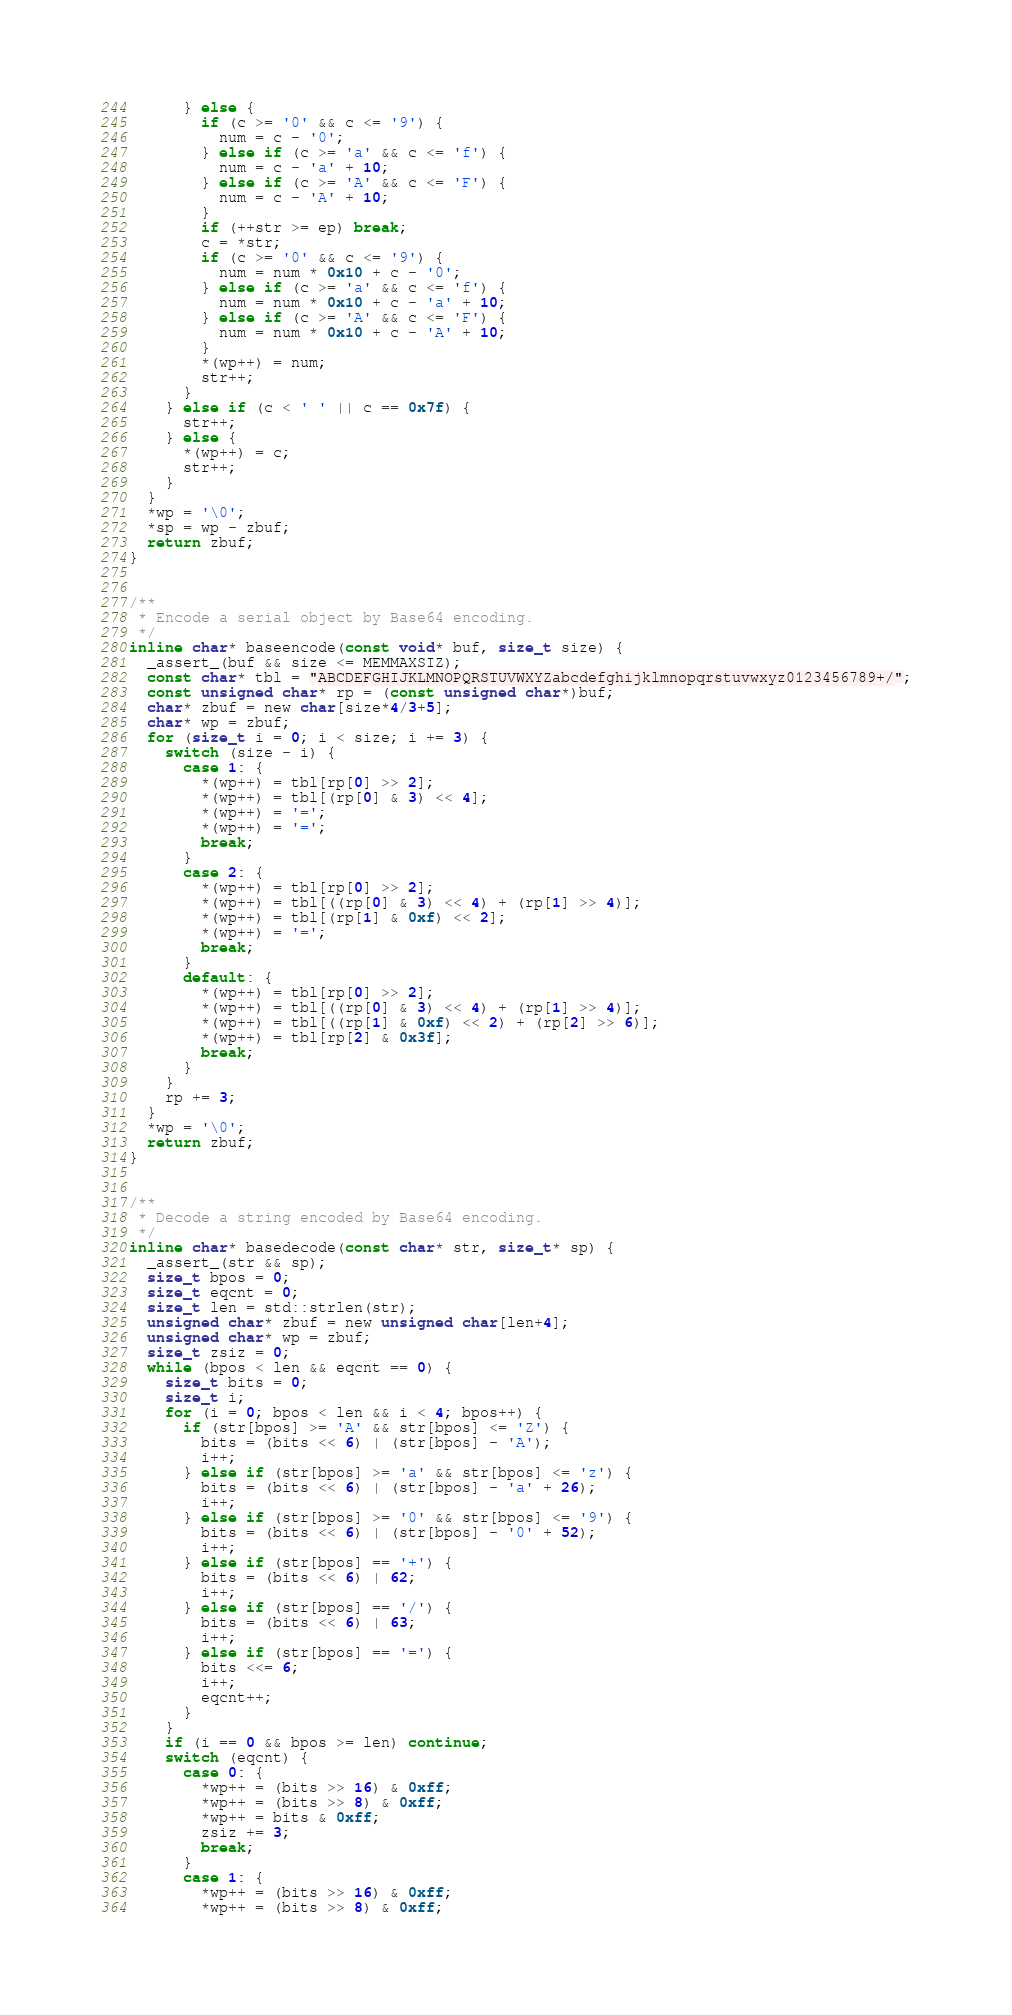<code> <loc_0><loc_0><loc_500><loc_500><_C_>      } else {
        if (c >= '0' && c <= '9') {
          num = c - '0';
        } else if (c >= 'a' && c <= 'f') {
          num = c - 'a' + 10;
        } else if (c >= 'A' && c <= 'F') {
          num = c - 'A' + 10;
        }
        if (++str >= ep) break;
        c = *str;
        if (c >= '0' && c <= '9') {
          num = num * 0x10 + c - '0';
        } else if (c >= 'a' && c <= 'f') {
          num = num * 0x10 + c - 'a' + 10;
        } else if (c >= 'A' && c <= 'F') {
          num = num * 0x10 + c - 'A' + 10;
        }
        *(wp++) = num;
        str++;
      }
    } else if (c < ' ' || c == 0x7f) {
      str++;
    } else {
      *(wp++) = c;
      str++;
    }
  }
  *wp = '\0';
  *sp = wp - zbuf;
  return zbuf;
}


/**
 * Encode a serial object by Base64 encoding.
 */
inline char* baseencode(const void* buf, size_t size) {
  _assert_(buf && size <= MEMMAXSIZ);
  const char* tbl = "ABCDEFGHIJKLMNOPQRSTUVWXYZabcdefghijklmnopqrstuvwxyz0123456789+/";
  const unsigned char* rp = (const unsigned char*)buf;
  char* zbuf = new char[size*4/3+5];
  char* wp = zbuf;
  for (size_t i = 0; i < size; i += 3) {
    switch (size - i) {
      case 1: {
        *(wp++) = tbl[rp[0] >> 2];
        *(wp++) = tbl[(rp[0] & 3) << 4];
        *(wp++) = '=';
        *(wp++) = '=';
        break;
      }
      case 2: {
        *(wp++) = tbl[rp[0] >> 2];
        *(wp++) = tbl[((rp[0] & 3) << 4) + (rp[1] >> 4)];
        *(wp++) = tbl[(rp[1] & 0xf) << 2];
        *(wp++) = '=';
        break;
      }
      default: {
        *(wp++) = tbl[rp[0] >> 2];
        *(wp++) = tbl[((rp[0] & 3) << 4) + (rp[1] >> 4)];
        *(wp++) = tbl[((rp[1] & 0xf) << 2) + (rp[2] >> 6)];
        *(wp++) = tbl[rp[2] & 0x3f];
        break;
      }
    }
    rp += 3;
  }
  *wp = '\0';
  return zbuf;
}


/**
 * Decode a string encoded by Base64 encoding.
 */
inline char* basedecode(const char* str, size_t* sp) {
  _assert_(str && sp);
  size_t bpos = 0;
  size_t eqcnt = 0;
  size_t len = std::strlen(str);
  unsigned char* zbuf = new unsigned char[len+4];
  unsigned char* wp = zbuf;
  size_t zsiz = 0;
  while (bpos < len && eqcnt == 0) {
    size_t bits = 0;
    size_t i;
    for (i = 0; bpos < len && i < 4; bpos++) {
      if (str[bpos] >= 'A' && str[bpos] <= 'Z') {
        bits = (bits << 6) | (str[bpos] - 'A');
        i++;
      } else if (str[bpos] >= 'a' && str[bpos] <= 'z') {
        bits = (bits << 6) | (str[bpos] - 'a' + 26);
        i++;
      } else if (str[bpos] >= '0' && str[bpos] <= '9') {
        bits = (bits << 6) | (str[bpos] - '0' + 52);
        i++;
      } else if (str[bpos] == '+') {
        bits = (bits << 6) | 62;
        i++;
      } else if (str[bpos] == '/') {
        bits = (bits << 6) | 63;
        i++;
      } else if (str[bpos] == '=') {
        bits <<= 6;
        i++;
        eqcnt++;
      }
    }
    if (i == 0 && bpos >= len) continue;
    switch (eqcnt) {
      case 0: {
        *wp++ = (bits >> 16) & 0xff;
        *wp++ = (bits >> 8) & 0xff;
        *wp++ = bits & 0xff;
        zsiz += 3;
        break;
      }
      case 1: {
        *wp++ = (bits >> 16) & 0xff;
        *wp++ = (bits >> 8) & 0xff;</code> 